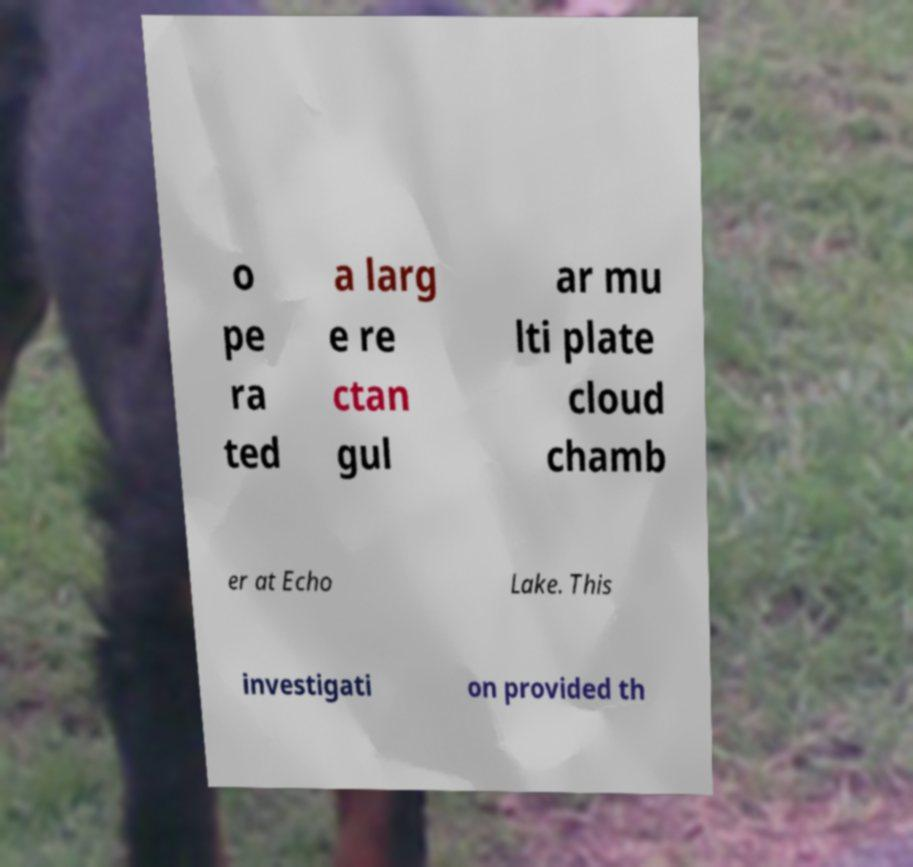Could you extract and type out the text from this image? o pe ra ted a larg e re ctan gul ar mu lti plate cloud chamb er at Echo Lake. This investigati on provided th 